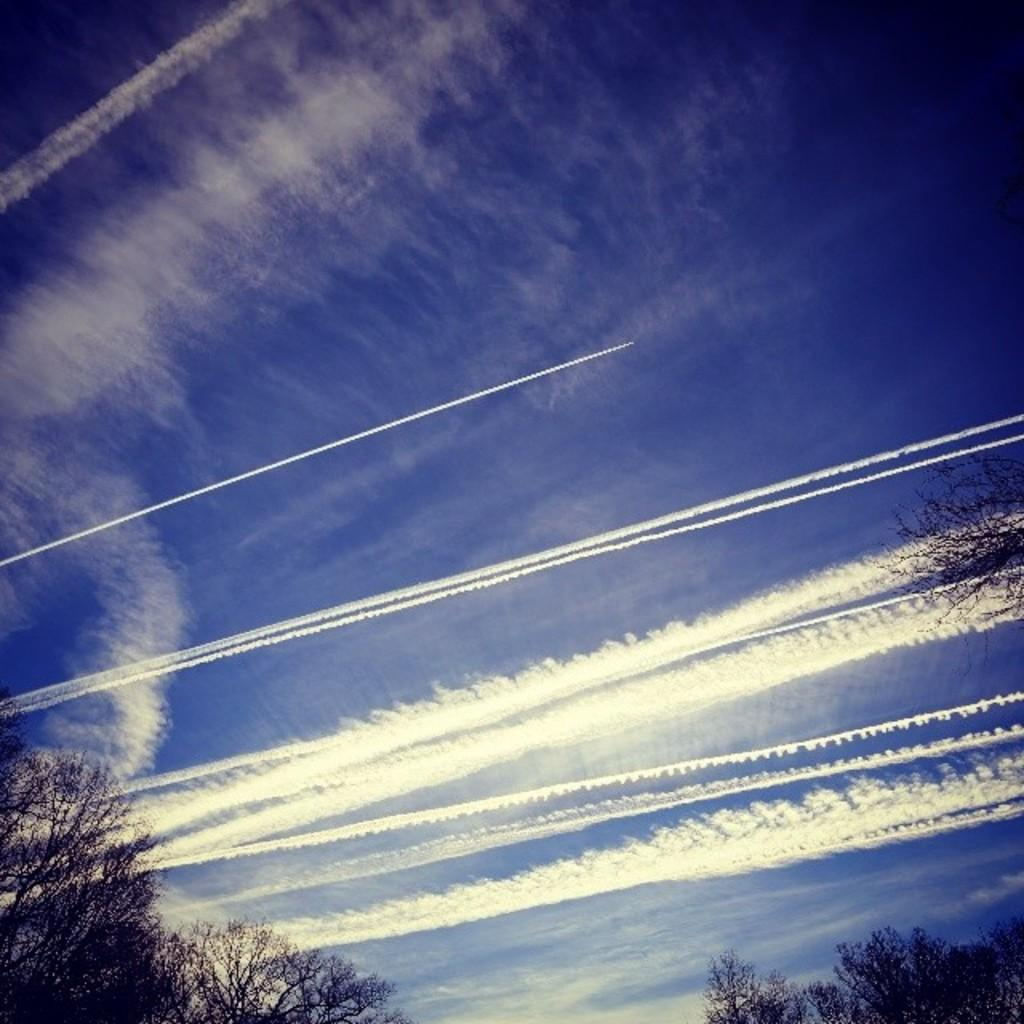What type of vegetation is present at the bottom of the image? There are trees at the bottom side of the image. What part of the natural environment is visible in the image? The sky is visible in the image. Can you see a gun in the image? There is no gun present in the image. What time of day is depicted in the image? The time of day cannot be determined from the image, as there are no specific indicators of morning or any other time. 